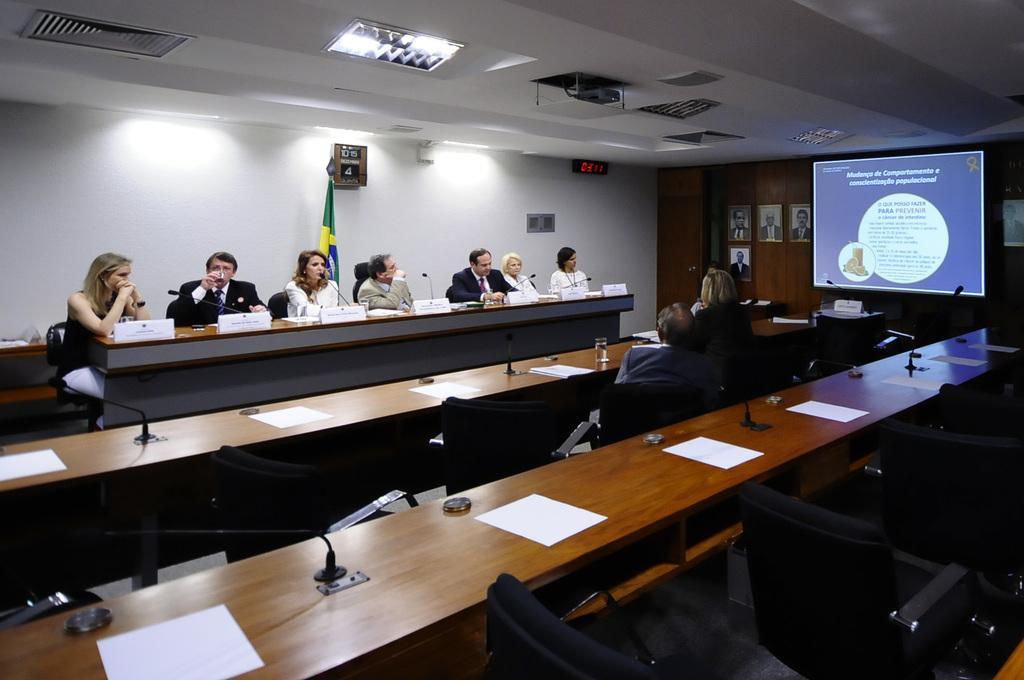Please provide a concise description of this image. There are some people sitting in the chairs in front of a table on which a name plates and mice were placed. There are men and women in this group. Some of the papers were placed on the table. In the background there is a projector display screen and some photographs attached to the wall here. 